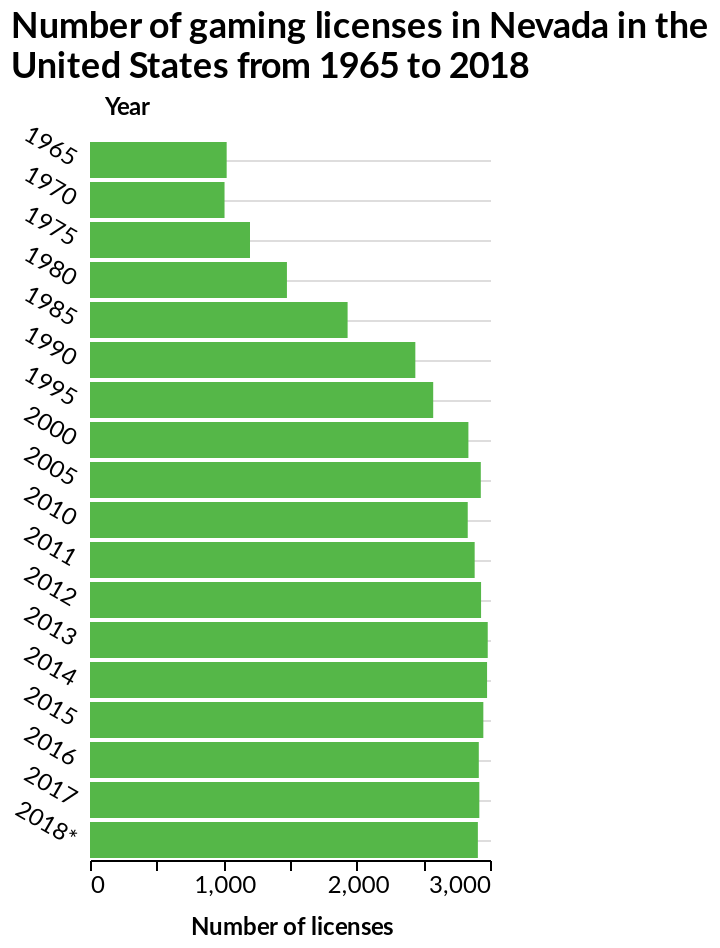<image>
Was there a consistent increase in gaming licenses after 1965? Yes, there was a consistent increase in gaming licenses between 1965 to 2000. Was there any significant change in the amount of gaming licenses after 2000? No, there was no significant change in the amount of gaming licenses after 2000. 